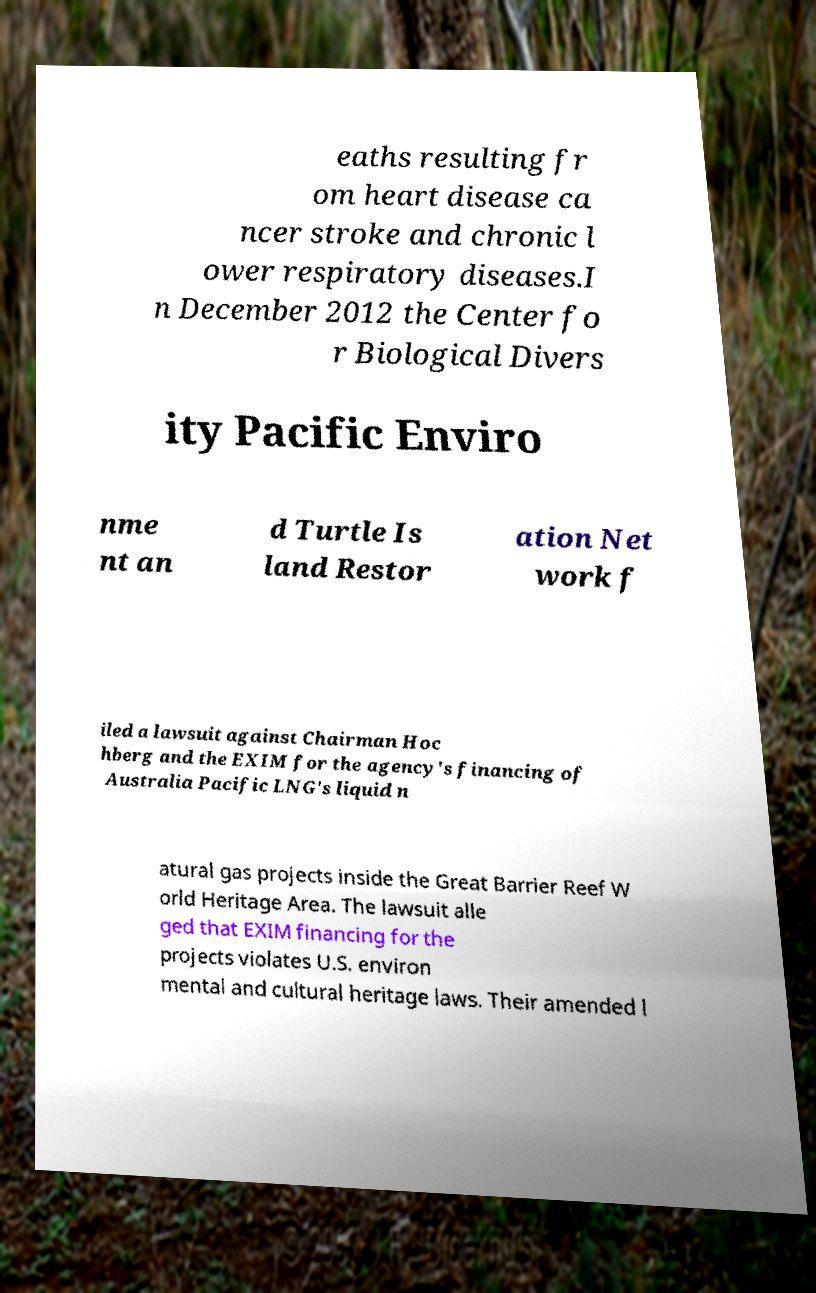There's text embedded in this image that I need extracted. Can you transcribe it verbatim? eaths resulting fr om heart disease ca ncer stroke and chronic l ower respiratory diseases.I n December 2012 the Center fo r Biological Divers ity Pacific Enviro nme nt an d Turtle Is land Restor ation Net work f iled a lawsuit against Chairman Hoc hberg and the EXIM for the agency's financing of Australia Pacific LNG's liquid n atural gas projects inside the Great Barrier Reef W orld Heritage Area. The lawsuit alle ged that EXIM financing for the projects violates U.S. environ mental and cultural heritage laws. Their amended l 